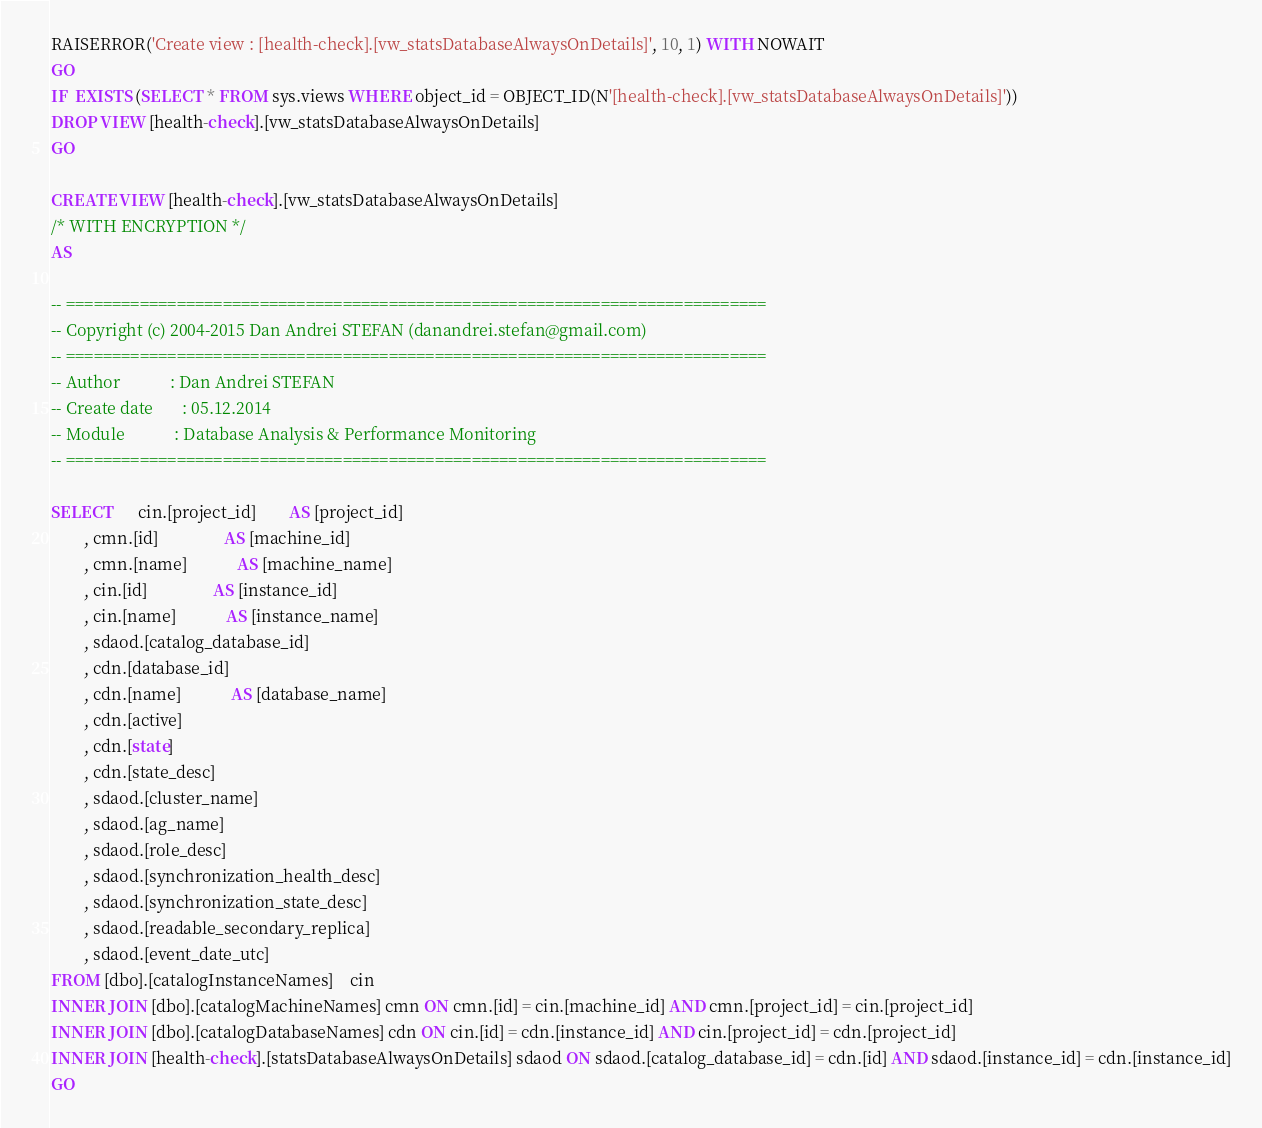<code> <loc_0><loc_0><loc_500><loc_500><_SQL_>RAISERROR('Create view : [health-check].[vw_statsDatabaseAlwaysOnDetails]', 10, 1) WITH NOWAIT
GO
IF  EXISTS (SELECT * FROM sys.views WHERE object_id = OBJECT_ID(N'[health-check].[vw_statsDatabaseAlwaysOnDetails]'))
DROP VIEW [health-check].[vw_statsDatabaseAlwaysOnDetails]
GO

CREATE VIEW [health-check].[vw_statsDatabaseAlwaysOnDetails]
/* WITH ENCRYPTION */
AS

-- ============================================================================
-- Copyright (c) 2004-2015 Dan Andrei STEFAN (danandrei.stefan@gmail.com)
-- ============================================================================
-- Author			 : Dan Andrei STEFAN
-- Create date		 : 05.12.2014
-- Module			 : Database Analysis & Performance Monitoring
-- ============================================================================

SELECT 	  cin.[project_id]		AS [project_id]
		, cmn.[id]				AS [machine_id]
		, cmn.[name]			AS [machine_name]
		, cin.[id]				AS [instance_id]
		, cin.[name]			AS [instance_name]
		, sdaod.[catalog_database_id]
		, cdn.[database_id]
		, cdn.[name]			AS [database_name]
		, cdn.[active]
		, cdn.[state]
		, cdn.[state_desc] 
		, sdaod.[cluster_name]
		, sdaod.[ag_name]
		, sdaod.[role_desc]
		, sdaod.[synchronization_health_desc]
		, sdaod.[synchronization_state_desc]
		, sdaod.[readable_secondary_replica]
		, sdaod.[event_date_utc]
FROM [dbo].[catalogInstanceNames]	cin	
INNER JOIN [dbo].[catalogMachineNames] cmn ON cmn.[id] = cin.[machine_id] AND cmn.[project_id] = cin.[project_id]
INNER JOIN [dbo].[catalogDatabaseNames] cdn ON cin.[id] = cdn.[instance_id] AND cin.[project_id] = cdn.[project_id]
INNER JOIN [health-check].[statsDatabaseAlwaysOnDetails] sdaod ON sdaod.[catalog_database_id] = cdn.[id] AND sdaod.[instance_id] = cdn.[instance_id]
GO



</code> 